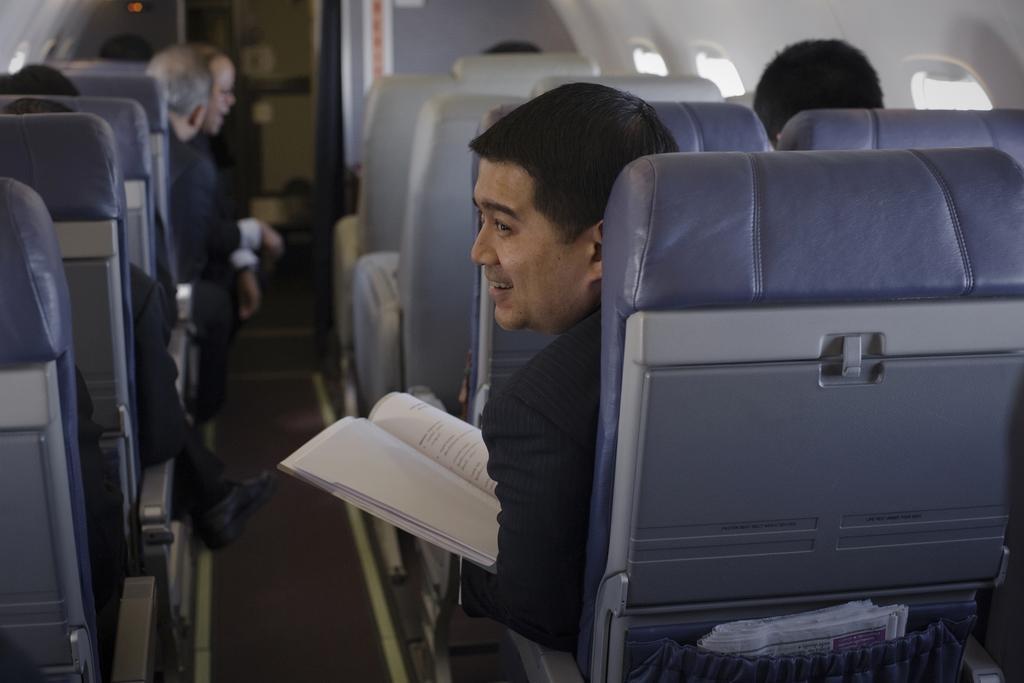Describe this image in one or two sentences. This picture is taken inside the airplane. In this image, on the right side, we can see some seats. In the seats, we can see a man is sitting and holding a book in his hand. On the left side, we can see a group of people are sitting on the chair. On the right side, we can also see a newspaper, we can also see some windows on the right side. 